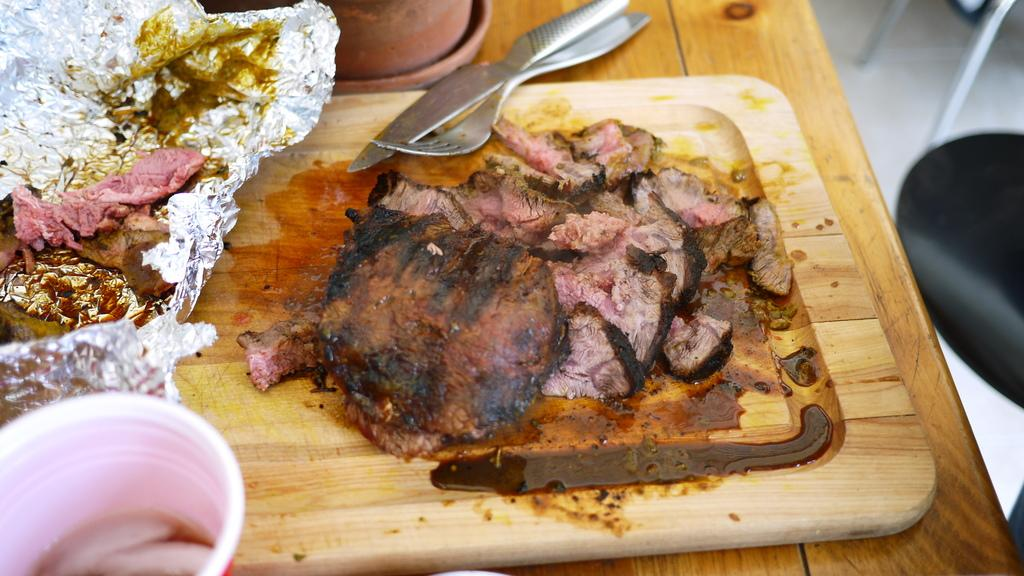What is the main piece of furniture in the image? There is a table in the image. What is placed on the table? There is a chopping board, meat, aluminium foil, a glass, a knife, a fork, and an object placed on the table. What can be used for cutting in the image? There is a knife on the table. What can be used for eating in the image? There is a fork on the table. What is on the right side of the image? There is a chair on the right side of the image. What type of sweater is draped over the chair in the image? There is no sweater present in the image; only a table, a chopping board, meat, aluminium foil, a glass, a knife, a fork, an object, and a chair are visible. 